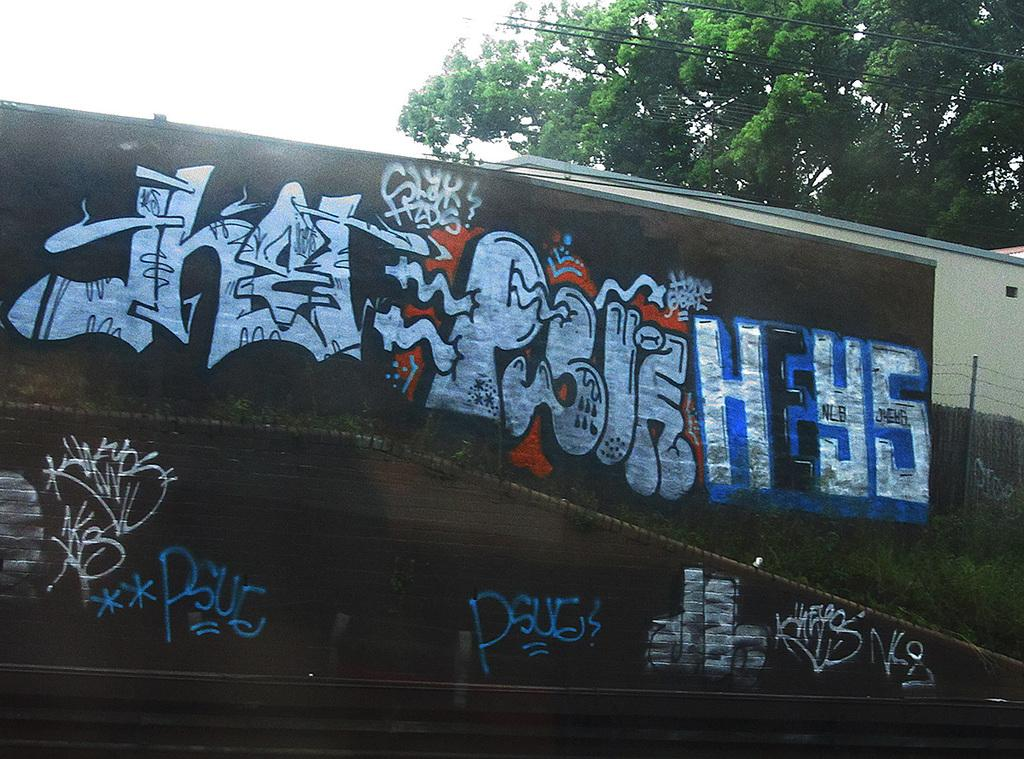What type of artwork can be seen on the walls in the image? There is graffiti on the walls in the image. What type of vegetation is present in the image? There are plants in the image. What type of barrier can be seen in the image? There is a fence in the image. What type of building is visible in the image? There is a house in the image. What else can be seen in the background of the image? There are wires, a tree, and the sky visible in the background. How many brothers are depicted in the graffiti on the walls? There are no brothers depicted in the graffiti on the walls; the graffiti is an artistic expression and does not contain any human figures. What type of fruit is hanging from the wires in the background? There are no fruits hanging from the wires in the background; only wires and a tree are visible. 